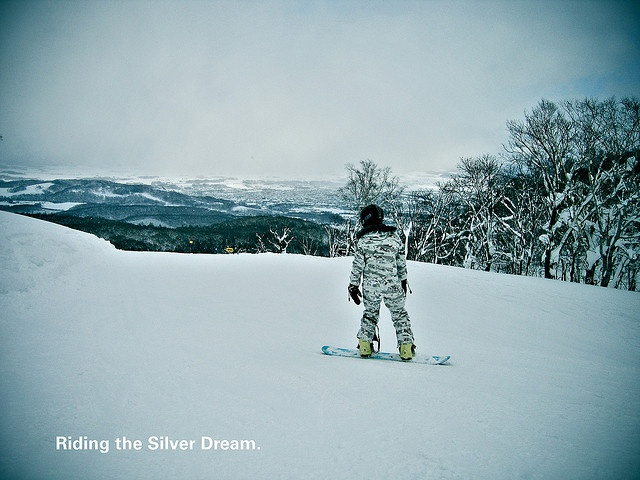Describe the objects in this image and their specific colors. I can see people in blue, black, darkgray, teal, and gray tones and snowboard in blue, darkgray, lightblue, and teal tones in this image. 